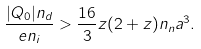<formula> <loc_0><loc_0><loc_500><loc_500>\frac { | Q _ { 0 } | n _ { d } } { e n _ { i } } > \frac { 1 6 } 3 z ( 2 + z ) n _ { n } a ^ { 3 } .</formula> 